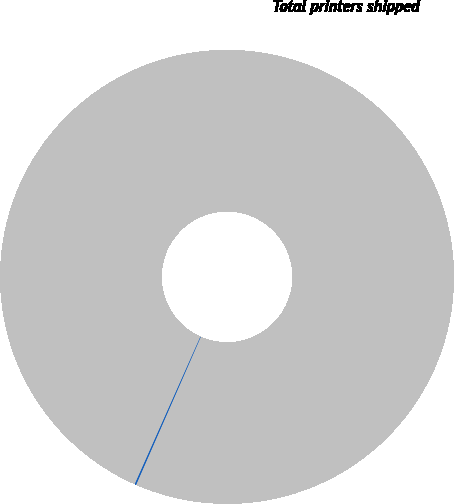Convert chart. <chart><loc_0><loc_0><loc_500><loc_500><pie_chart><fcel>Total printers shipped<fcel>Average selling price of<nl><fcel>99.9%<fcel>0.1%<nl></chart> 